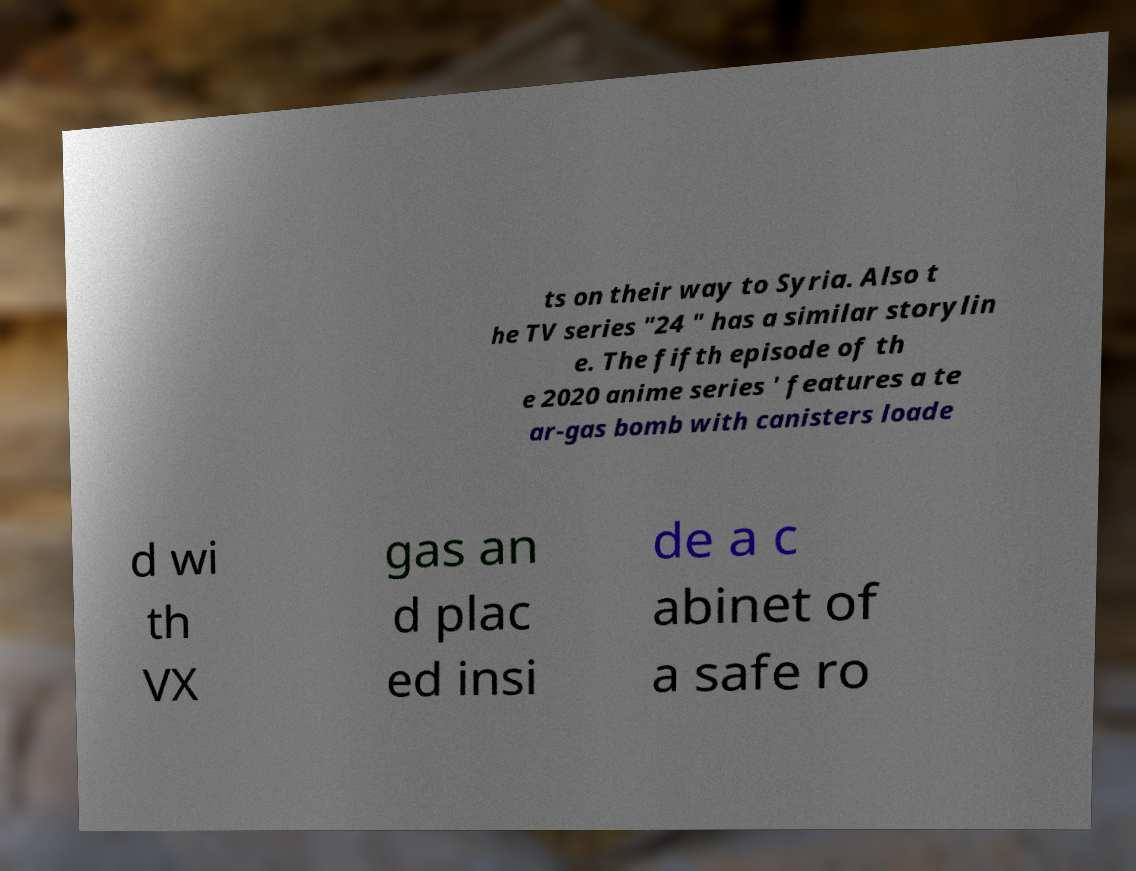Can you accurately transcribe the text from the provided image for me? ts on their way to Syria. Also t he TV series "24 " has a similar storylin e. The fifth episode of th e 2020 anime series ' features a te ar-gas bomb with canisters loade d wi th VX gas an d plac ed insi de a c abinet of a safe ro 